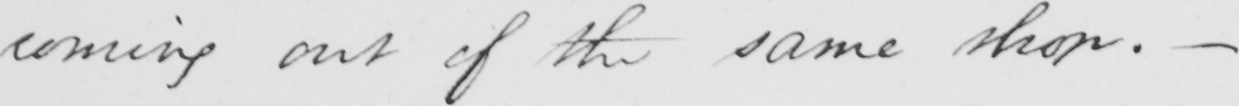Can you read and transcribe this handwriting? coming out of the same shop .  _ 